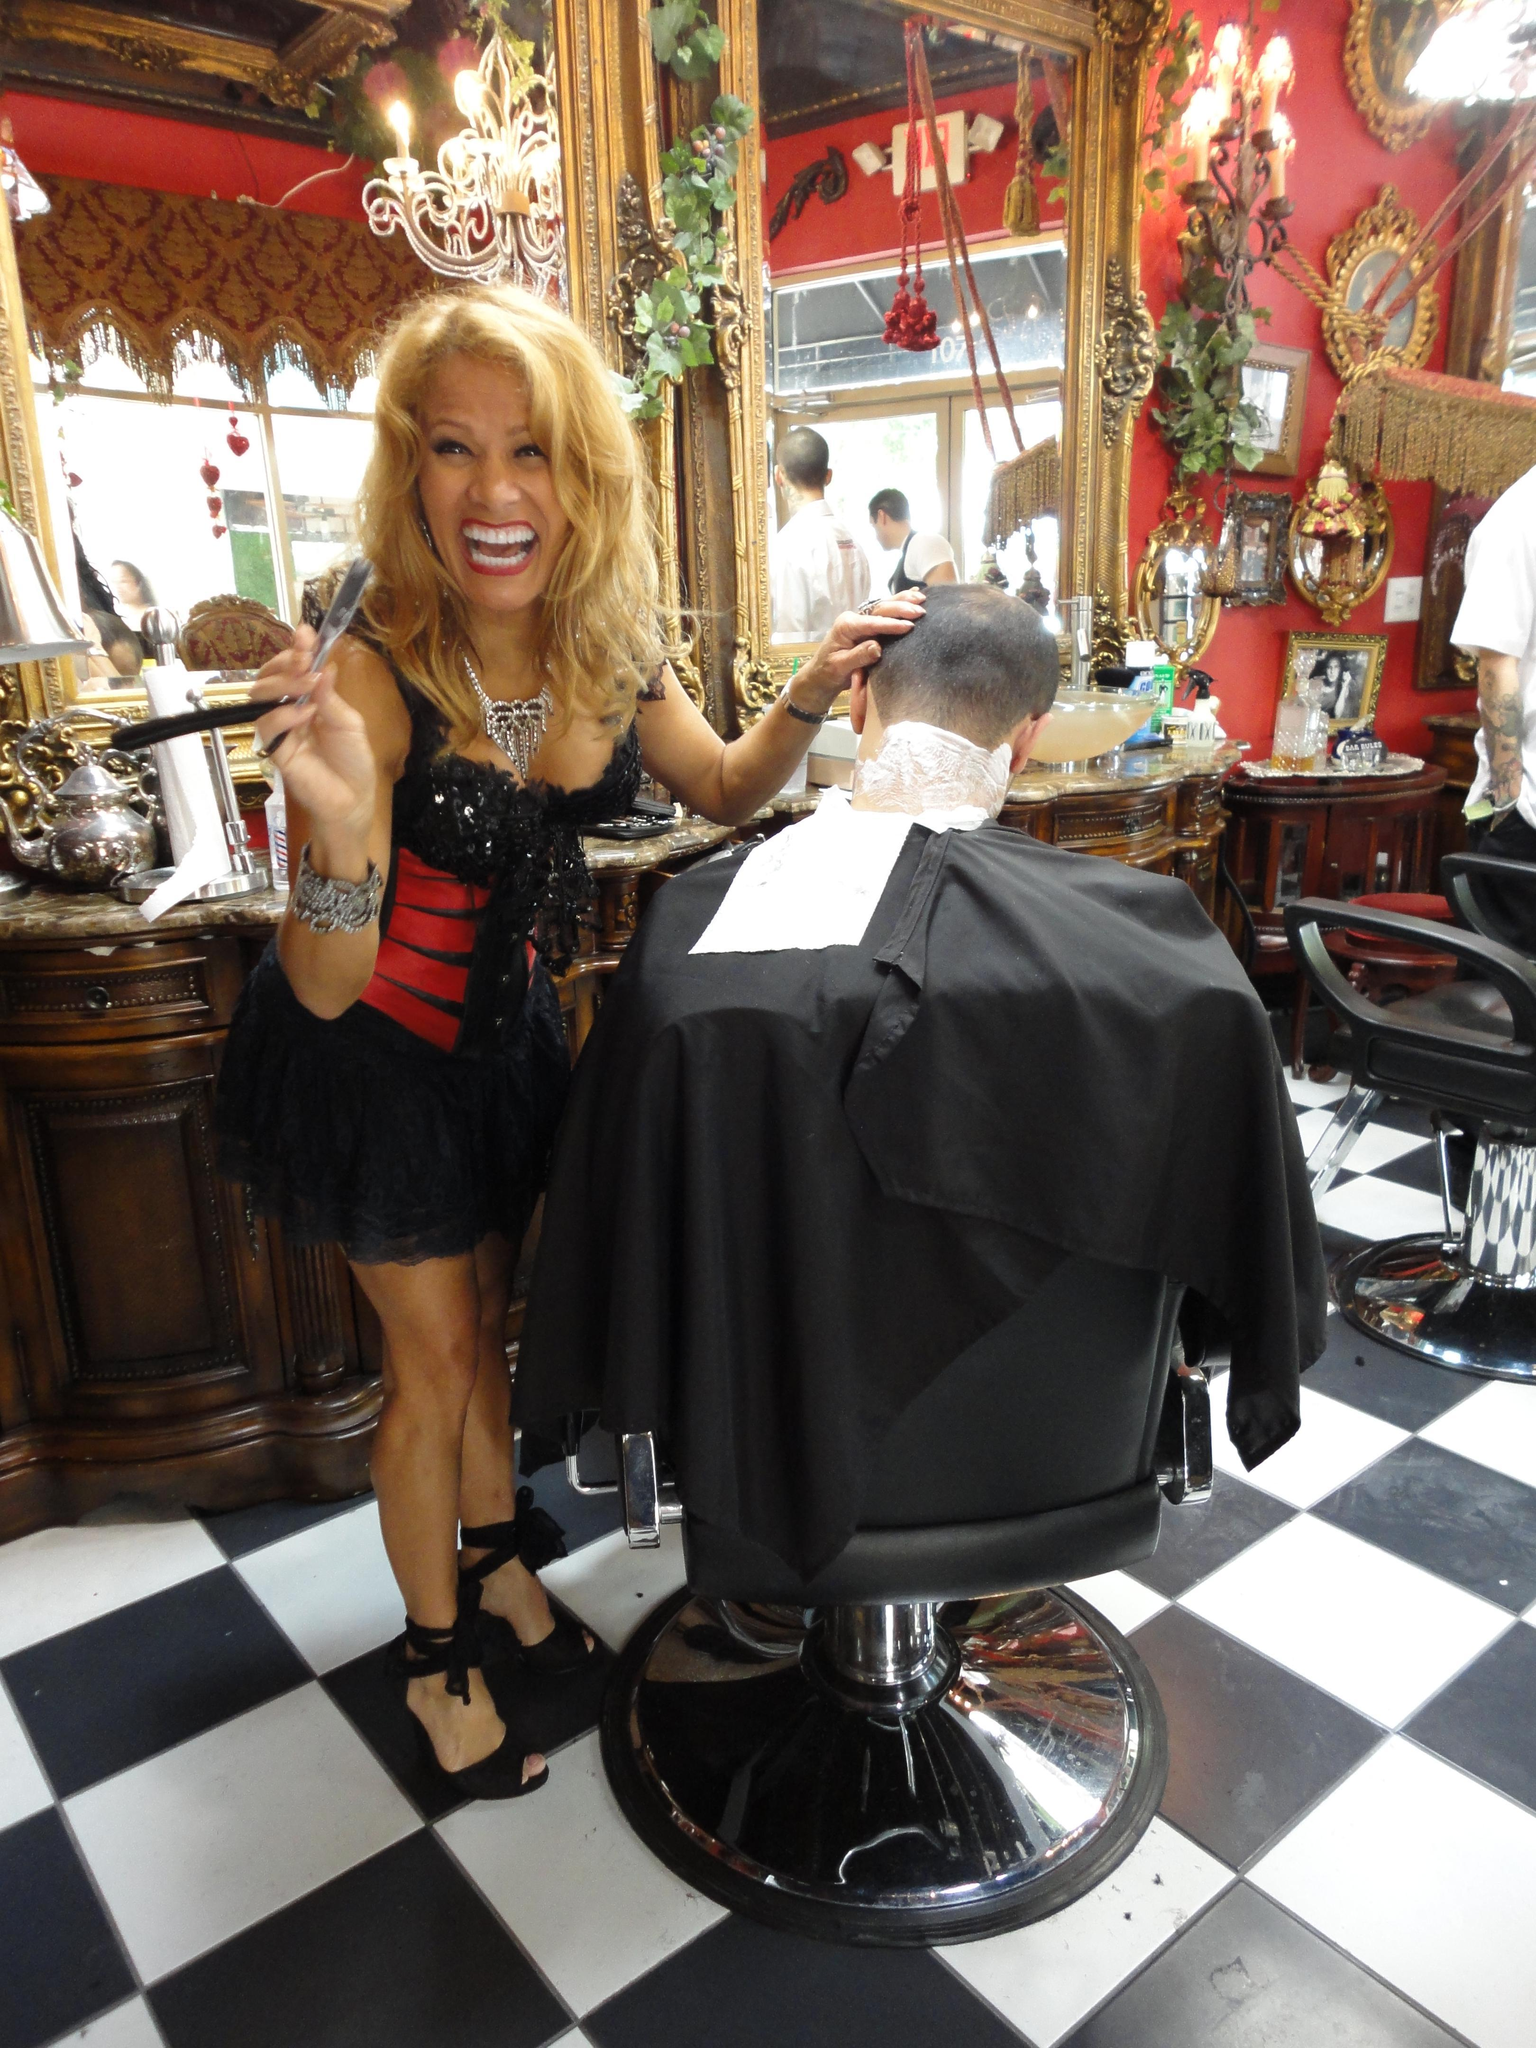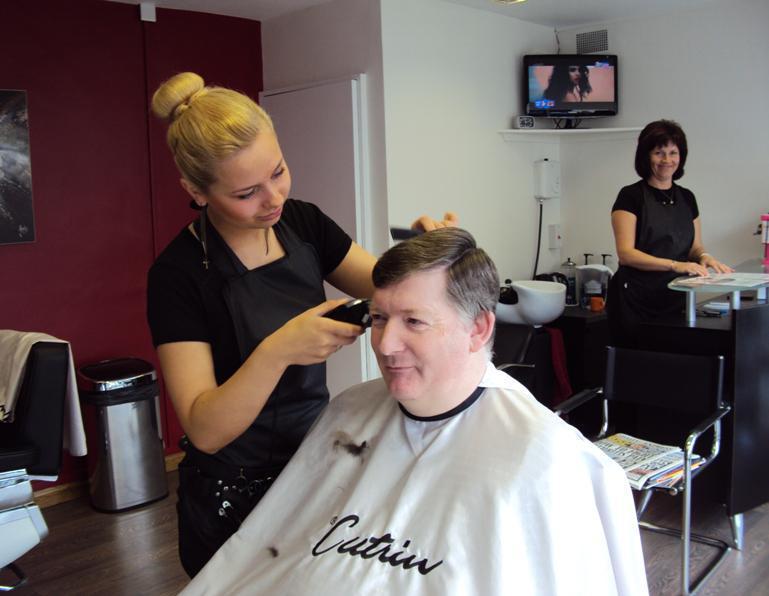The first image is the image on the left, the second image is the image on the right. Considering the images on both sides, is "At least one of the images has someone getting their hair cut with a purple apron over their laps." valid? Answer yes or no. No. The first image is the image on the left, the second image is the image on the right. Considering the images on both sides, is "An image shows salon customers wearing purple protective capes." valid? Answer yes or no. No. 